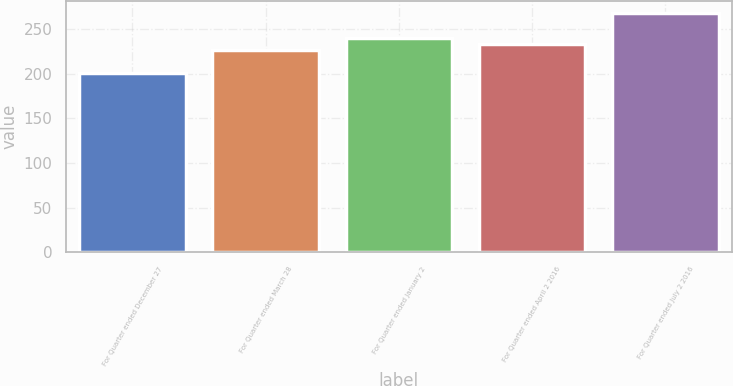Convert chart. <chart><loc_0><loc_0><loc_500><loc_500><bar_chart><fcel>For Quarter ended December 27<fcel>For Quarter ended March 28<fcel>For Quarter ended January 2<fcel>For Quarter ended April 2 2016<fcel>For Quarter ended July 2 2016<nl><fcel>201.04<fcel>226.21<fcel>239.61<fcel>232.91<fcel>268<nl></chart> 